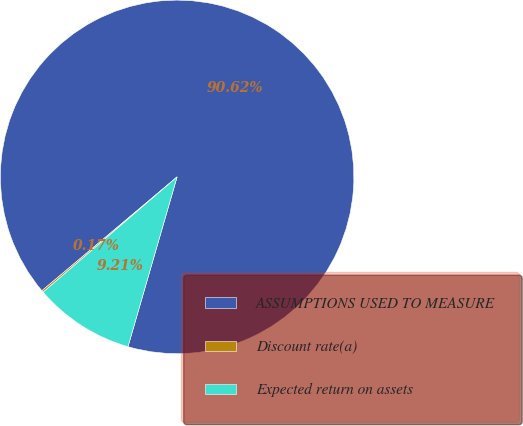Convert chart. <chart><loc_0><loc_0><loc_500><loc_500><pie_chart><fcel>ASSUMPTIONS USED TO MEASURE<fcel>Discount rate(a)<fcel>Expected return on assets<nl><fcel>90.62%<fcel>0.17%<fcel>9.21%<nl></chart> 